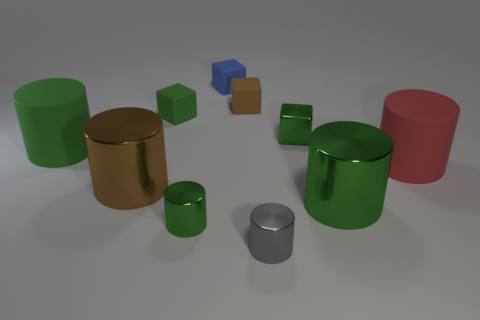What shape is the green metal object that is the same size as the brown shiny object?
Your answer should be very brief. Cylinder. Are there any green cylinders behind the tiny green shiny cube?
Provide a short and direct response. No. Are there any brown objects on the right side of the small green shiny thing behind the large green matte cylinder?
Your answer should be very brief. No. Is the number of rubber cylinders that are on the right side of the small green cylinder less than the number of green matte things on the left side of the big green shiny thing?
Give a very brief answer. Yes. The brown shiny thing has what shape?
Your answer should be compact. Cylinder. There is a tiny gray object in front of the tiny brown object; what is it made of?
Make the answer very short. Metal. What is the size of the green cylinder to the right of the tiny green metallic object left of the tiny thing that is right of the gray metal cylinder?
Give a very brief answer. Large. Is the big green thing in front of the big brown metal object made of the same material as the green object left of the brown shiny object?
Give a very brief answer. No. What number of other things are the same color as the small shiny cube?
Make the answer very short. 4. How many objects are big matte things that are right of the brown cylinder or blocks to the left of the tiny blue cube?
Provide a succinct answer. 2. 